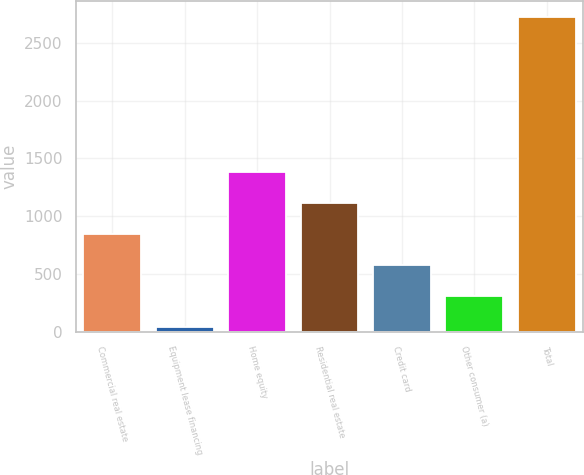<chart> <loc_0><loc_0><loc_500><loc_500><bar_chart><fcel>Commercial real estate<fcel>Equipment lease financing<fcel>Home equity<fcel>Residential real estate<fcel>Credit card<fcel>Other consumer (a)<fcel>Total<nl><fcel>844.7<fcel>38<fcel>1382.5<fcel>1113.6<fcel>575.8<fcel>306.9<fcel>2727<nl></chart> 